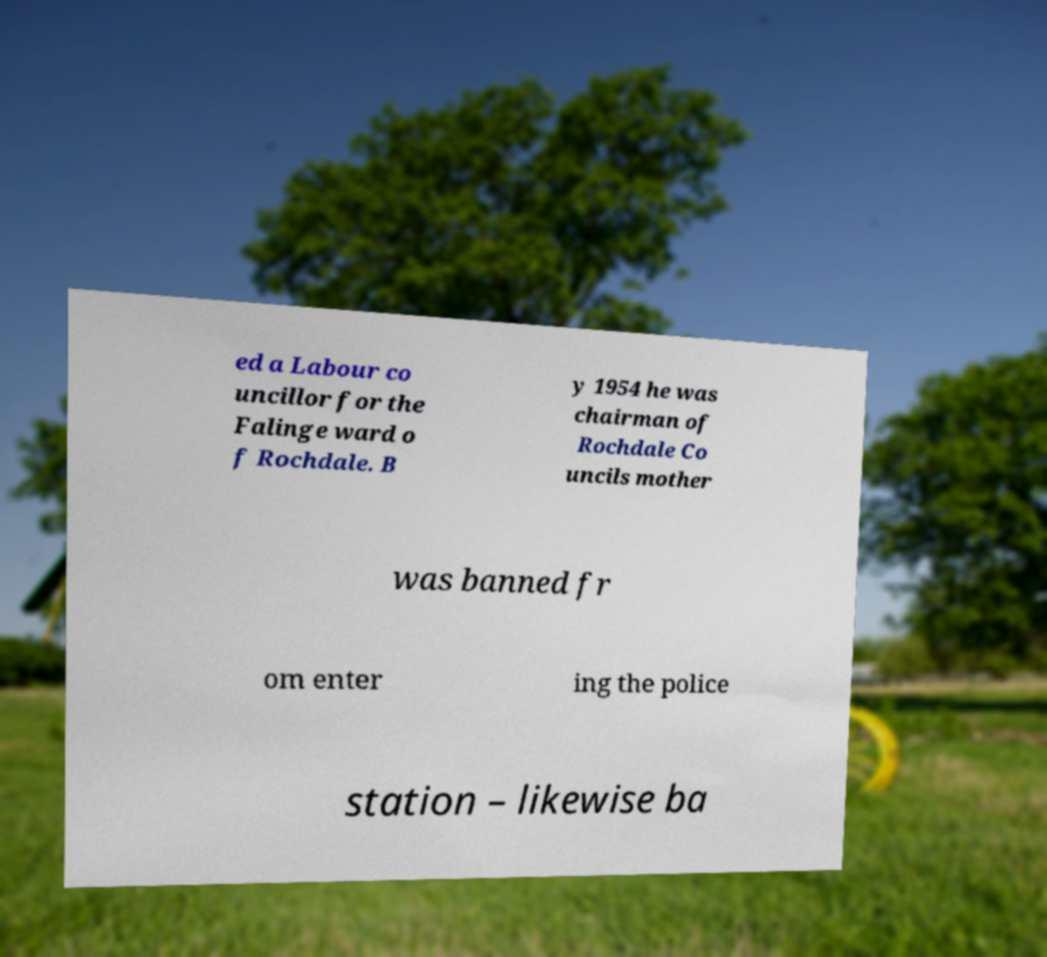There's text embedded in this image that I need extracted. Can you transcribe it verbatim? ed a Labour co uncillor for the Falinge ward o f Rochdale. B y 1954 he was chairman of Rochdale Co uncils mother was banned fr om enter ing the police station – likewise ba 